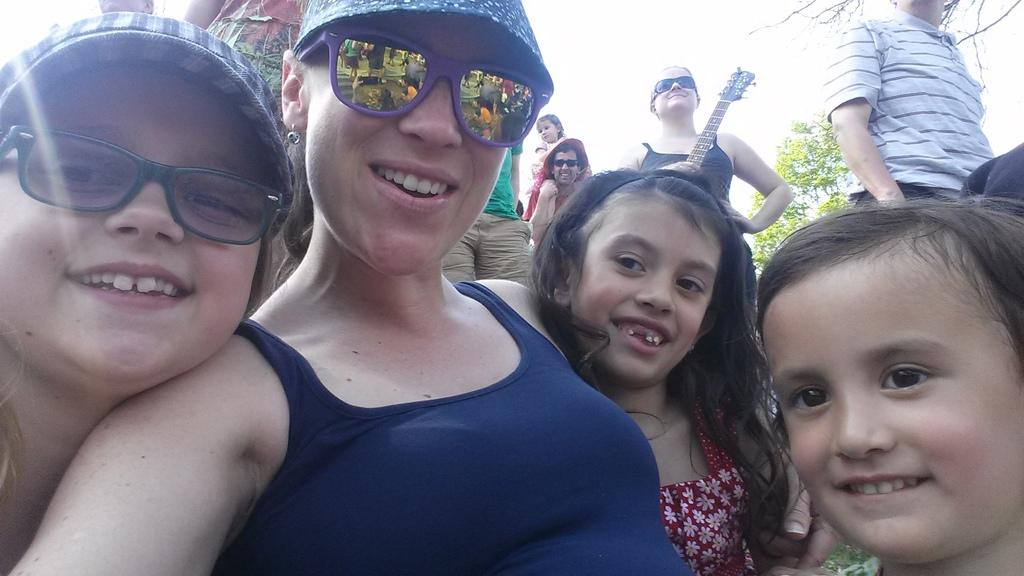How many persons are in the image? There are persons in the image. What is the facial expression of the persons in the image? The persons are smiling. Can you describe any accessories worn by the persons in the image? A person is wearing goggles, and another person is wearing a cap. What activity might the person holding a guitar be engaged in? The person holding a guitar might be playing music. What type of vegetation is visible in the image? There is a tree in the image. What part of the natural environment is visible in the image? The sky is visible in the image. What type of banana is being used as a pen in the image? There is no banana or pen present in the image. Can you confirm the existence of an invisible elephant in the image? There is no mention of an invisible elephant or any other invisible objects in the image. 